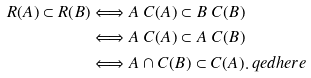Convert formula to latex. <formula><loc_0><loc_0><loc_500><loc_500>R ( A ) \subset R ( B ) & \Longleftrightarrow A \ C ( A ) \subset B \ C ( B ) \\ & \Longleftrightarrow A \ C ( A ) \subset A \ C ( B ) \\ & \Longleftrightarrow A \cap C ( B ) \subset C ( A ) . \ q e d h e r e</formula> 